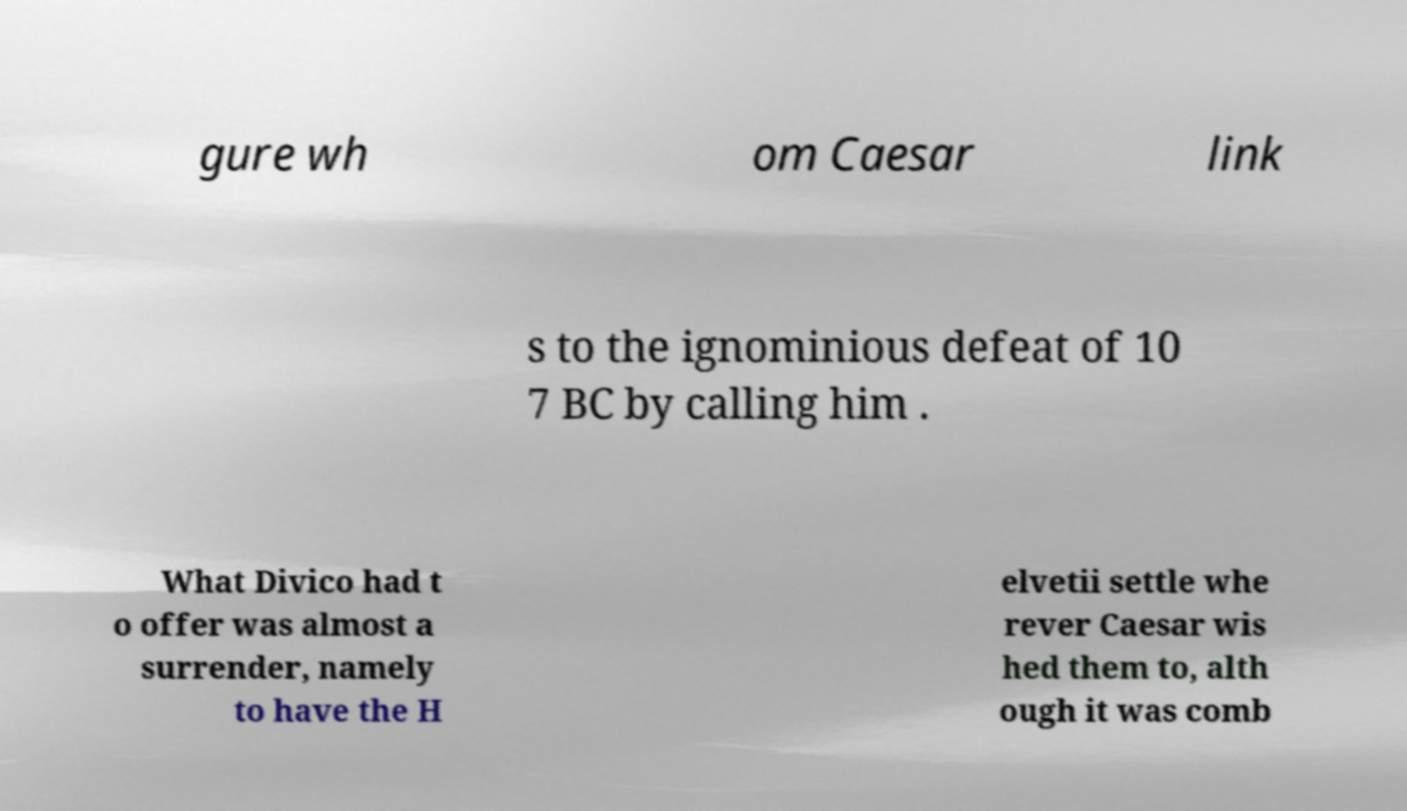Please identify and transcribe the text found in this image. gure wh om Caesar link s to the ignominious defeat of 10 7 BC by calling him . What Divico had t o offer was almost a surrender, namely to have the H elvetii settle whe rever Caesar wis hed them to, alth ough it was comb 